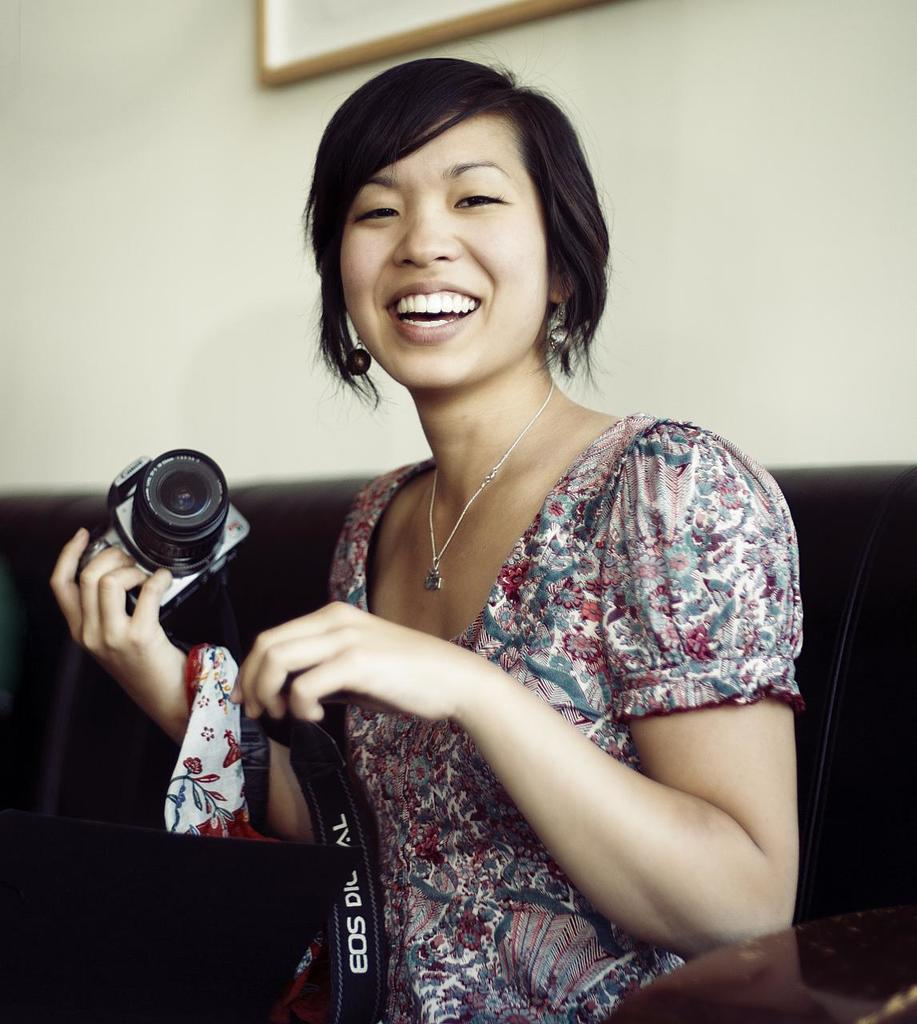Who is the main subject in the image? There is a woman in the image. What is the woman doing in the image? The woman is standing and holding a camera in her hand. What is the woman's facial expression in the image? The woman is smiling in the image. What type of air can be seen in the image? There is no air visible in the image; it is a photograph of a woman holding a camera. Can you tell me who the guide is in the image? There is no guide present in the image; it is a photograph of a woman holding a camera. 